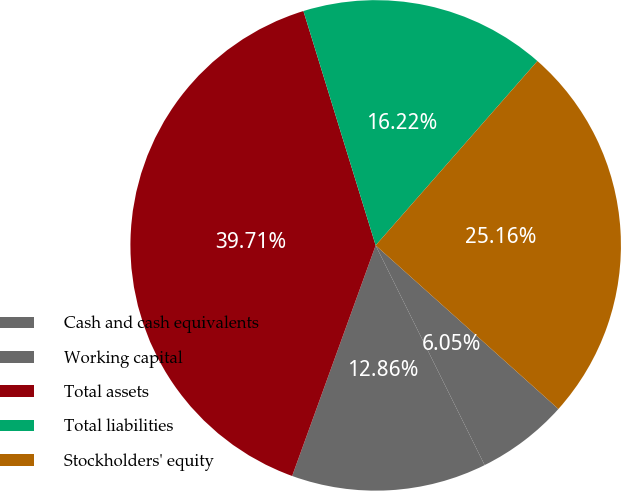<chart> <loc_0><loc_0><loc_500><loc_500><pie_chart><fcel>Cash and cash equivalents<fcel>Working capital<fcel>Total assets<fcel>Total liabilities<fcel>Stockholders' equity<nl><fcel>6.05%<fcel>12.86%<fcel>39.71%<fcel>16.22%<fcel>25.16%<nl></chart> 